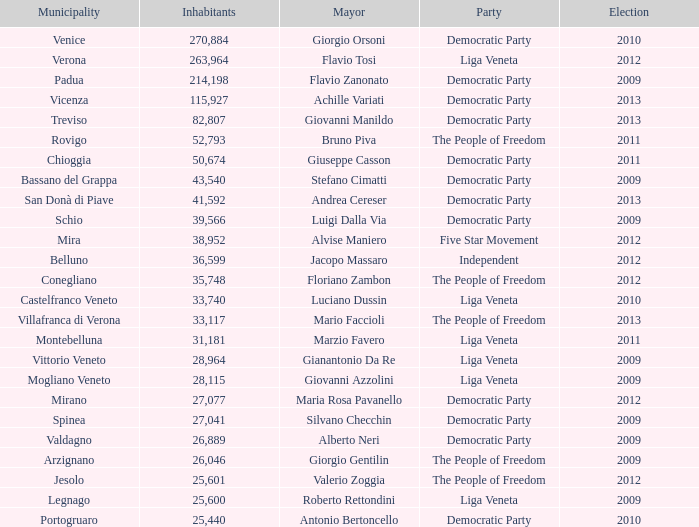When giovanni manildo was mayor, in how many elections did the number of inhabitants exceed 36,599? 1.0. 